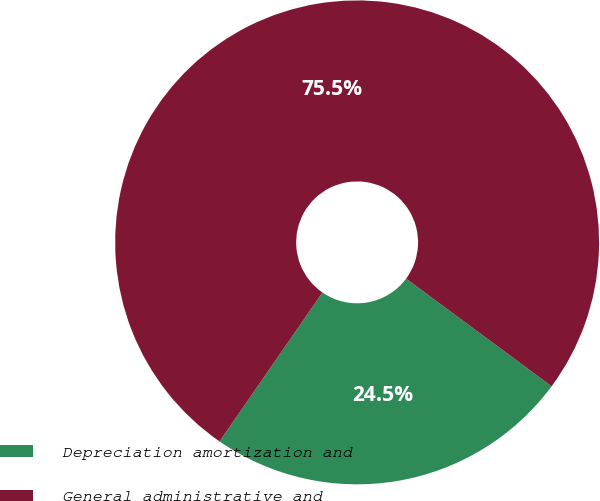Convert chart. <chart><loc_0><loc_0><loc_500><loc_500><pie_chart><fcel>Depreciation amortization and<fcel>General administrative and<nl><fcel>24.49%<fcel>75.51%<nl></chart> 